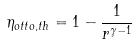<formula> <loc_0><loc_0><loc_500><loc_500>\eta _ { o t t o , t h } = 1 - \frac { 1 } { r ^ { \gamma - 1 } }</formula> 